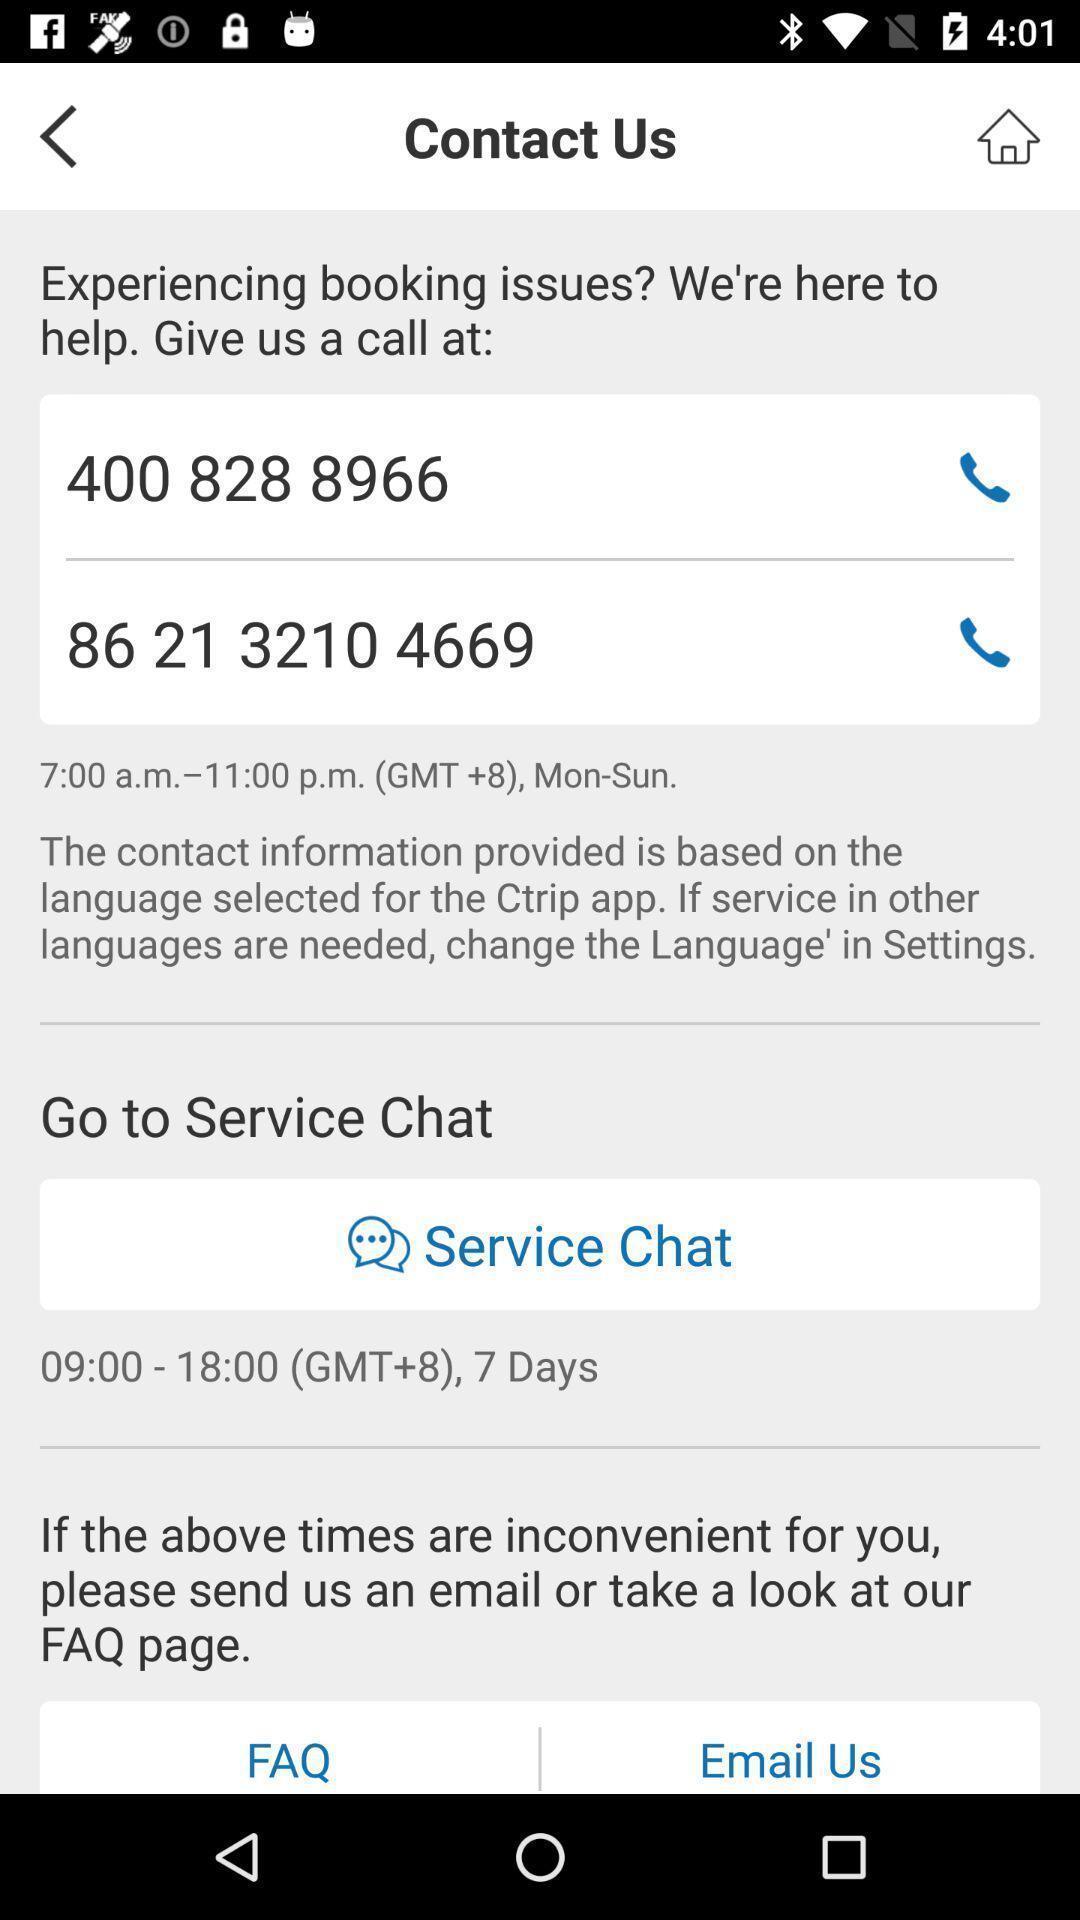Provide a description of this screenshot. Service numbers to connect for service. 